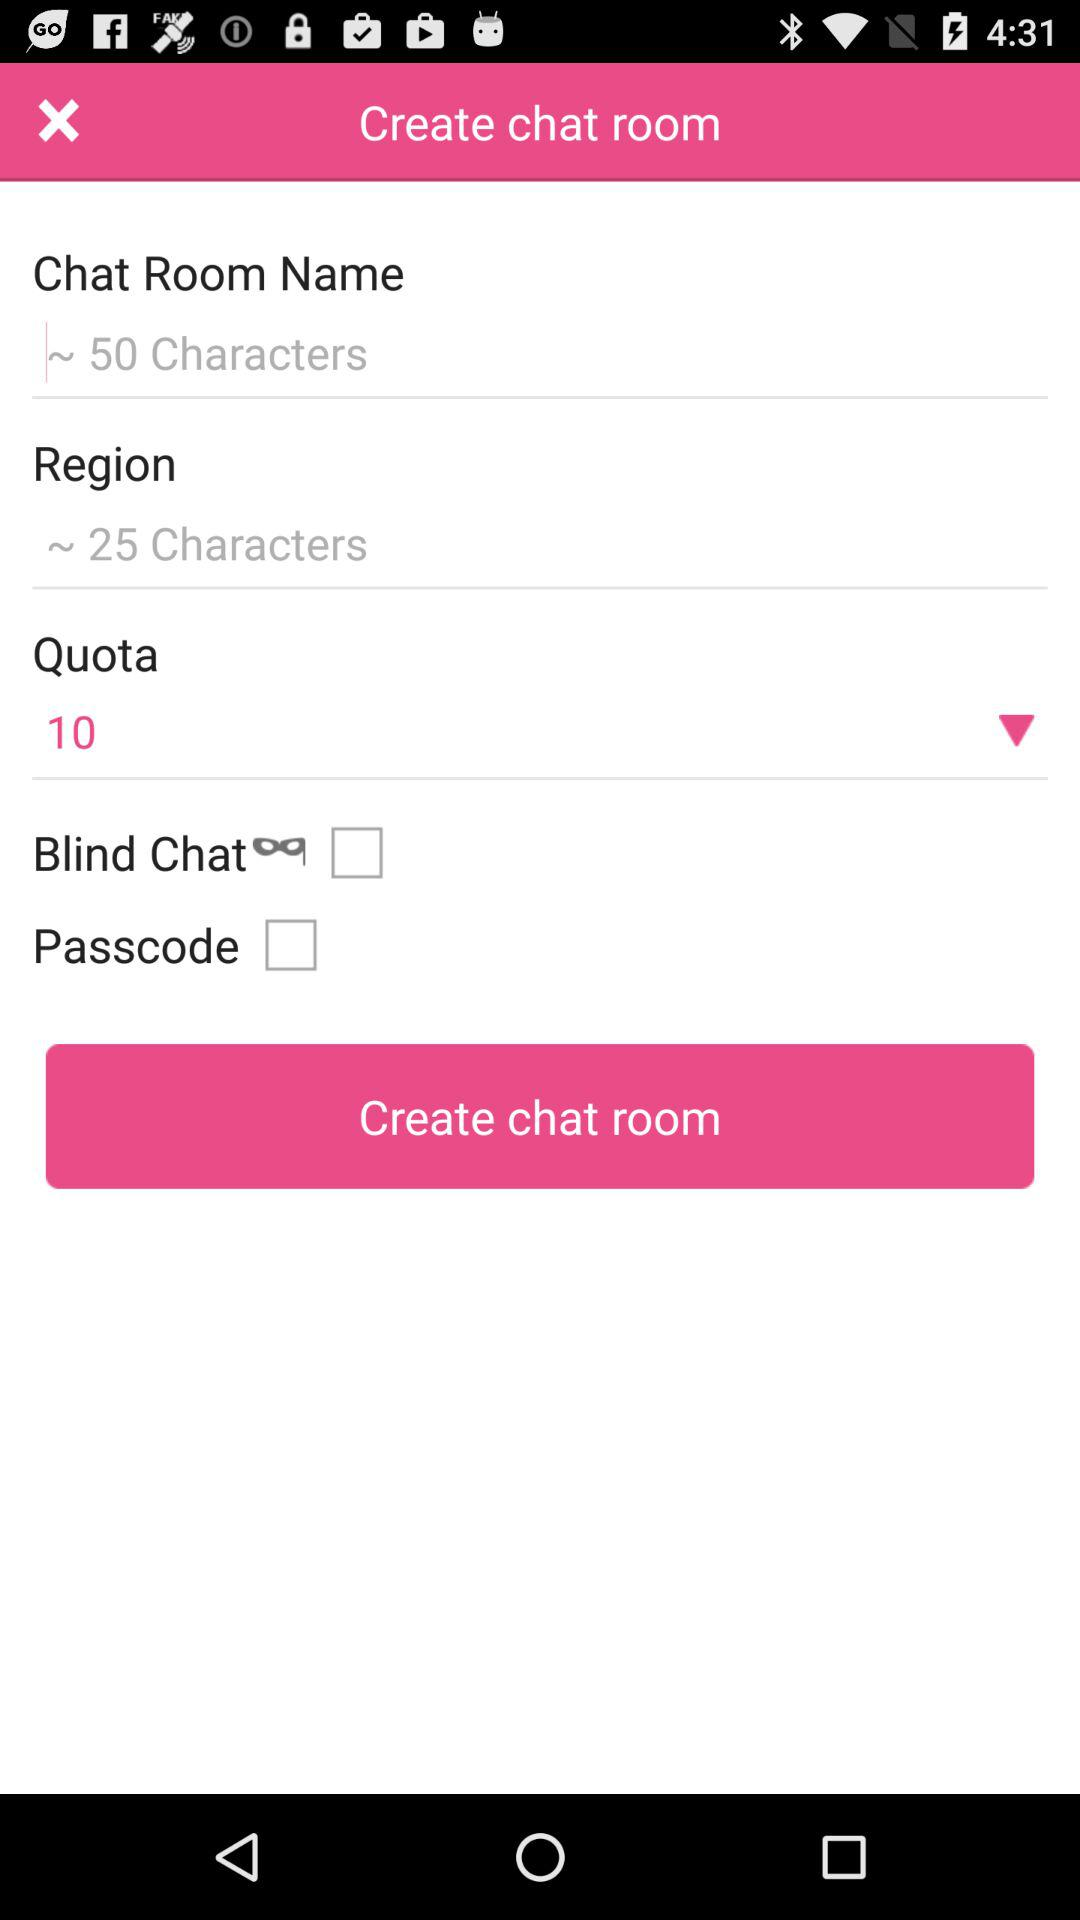What is the limit of characters in the chat room name? The limit is "~ 50 Characters". 